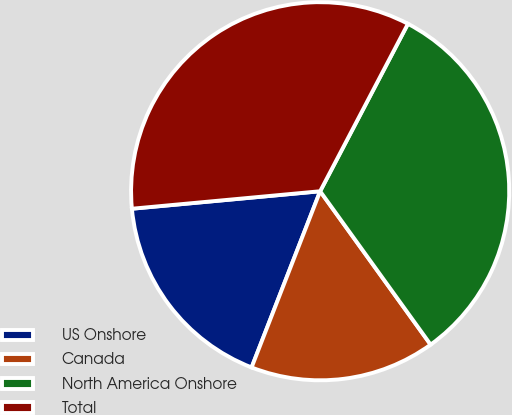Convert chart to OTSL. <chart><loc_0><loc_0><loc_500><loc_500><pie_chart><fcel>US Onshore<fcel>Canada<fcel>North America Onshore<fcel>Total<nl><fcel>17.62%<fcel>15.84%<fcel>32.38%<fcel>34.16%<nl></chart> 